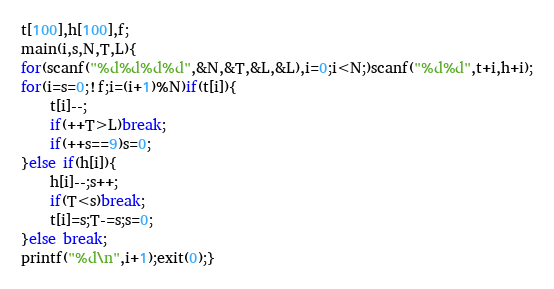Convert code to text. <code><loc_0><loc_0><loc_500><loc_500><_C_>t[100],h[100],f;
main(i,s,N,T,L){
for(scanf("%d%d%d%d",&N,&T,&L,&L),i=0;i<N;)scanf("%d%d",t+i,h+i);
for(i=s=0;!f;i=(i+1)%N)if(t[i]){
	t[i]--;
	if(++T>L)break;
	if(++s==9)s=0;
}else if(h[i]){
	h[i]--;s++;
	if(T<s)break;
	t[i]=s;T-=s;s=0;
}else break;
printf("%d\n",i+1);exit(0);}</code> 